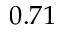<formula> <loc_0><loc_0><loc_500><loc_500>0 . 7 1</formula> 